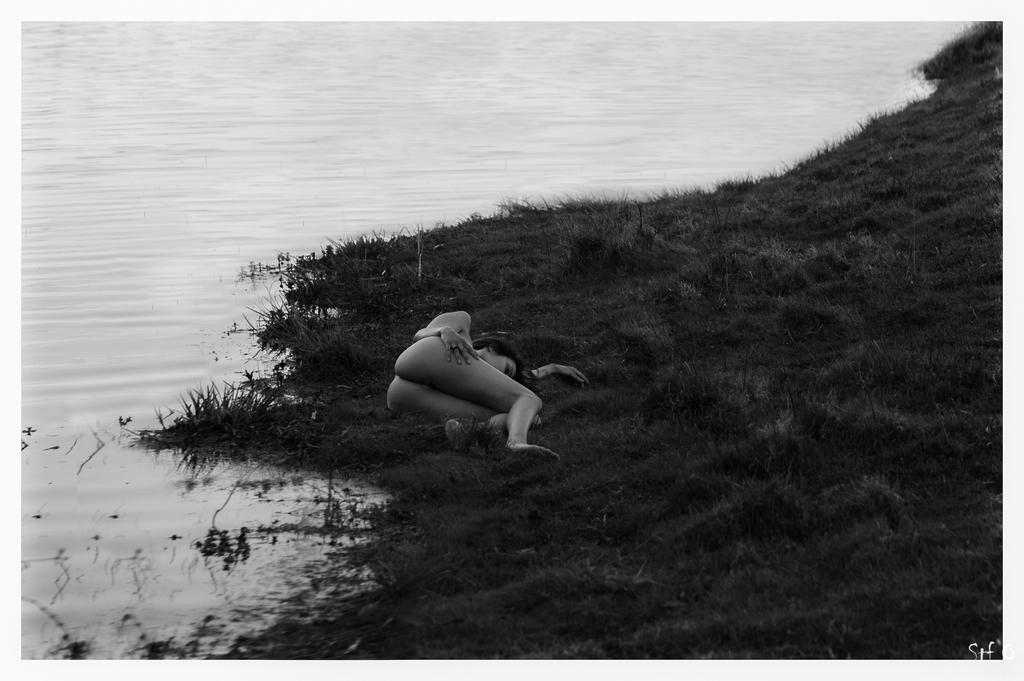What is the color scheme of the image? The image is black and white. What is the person in the image doing? The person is lying on a grass path. What can be seen behind the person? There is water visible behind the person. What type of volleyball game is being played in the image? There is no volleyball game present in the image. How does the person's digestion appear to be affected by the grass path in the image? There is no indication of the person's digestion in the image, and the grass path is not related to digestion. 